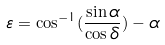Convert formula to latex. <formula><loc_0><loc_0><loc_500><loc_500>\varepsilon = \cos ^ { - 1 } ( \frac { \sin \alpha } { \cos \delta } ) - \alpha</formula> 